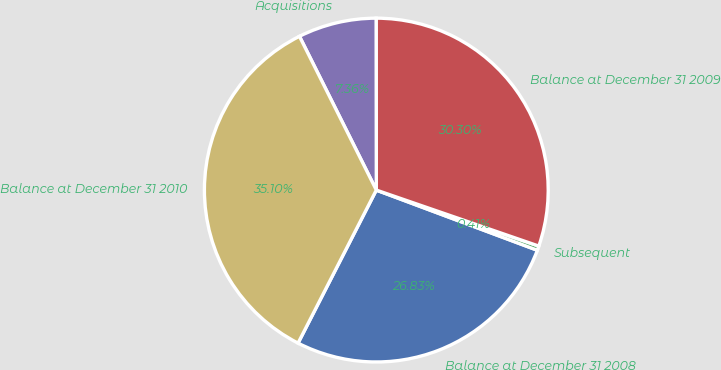Convert chart. <chart><loc_0><loc_0><loc_500><loc_500><pie_chart><fcel>Balance at December 31 2008<fcel>Subsequent<fcel>Balance at December 31 2009<fcel>Acquisitions<fcel>Balance at December 31 2010<nl><fcel>26.83%<fcel>0.41%<fcel>30.3%<fcel>7.36%<fcel>35.1%<nl></chart> 